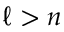Convert formula to latex. <formula><loc_0><loc_0><loc_500><loc_500>\ell > n</formula> 